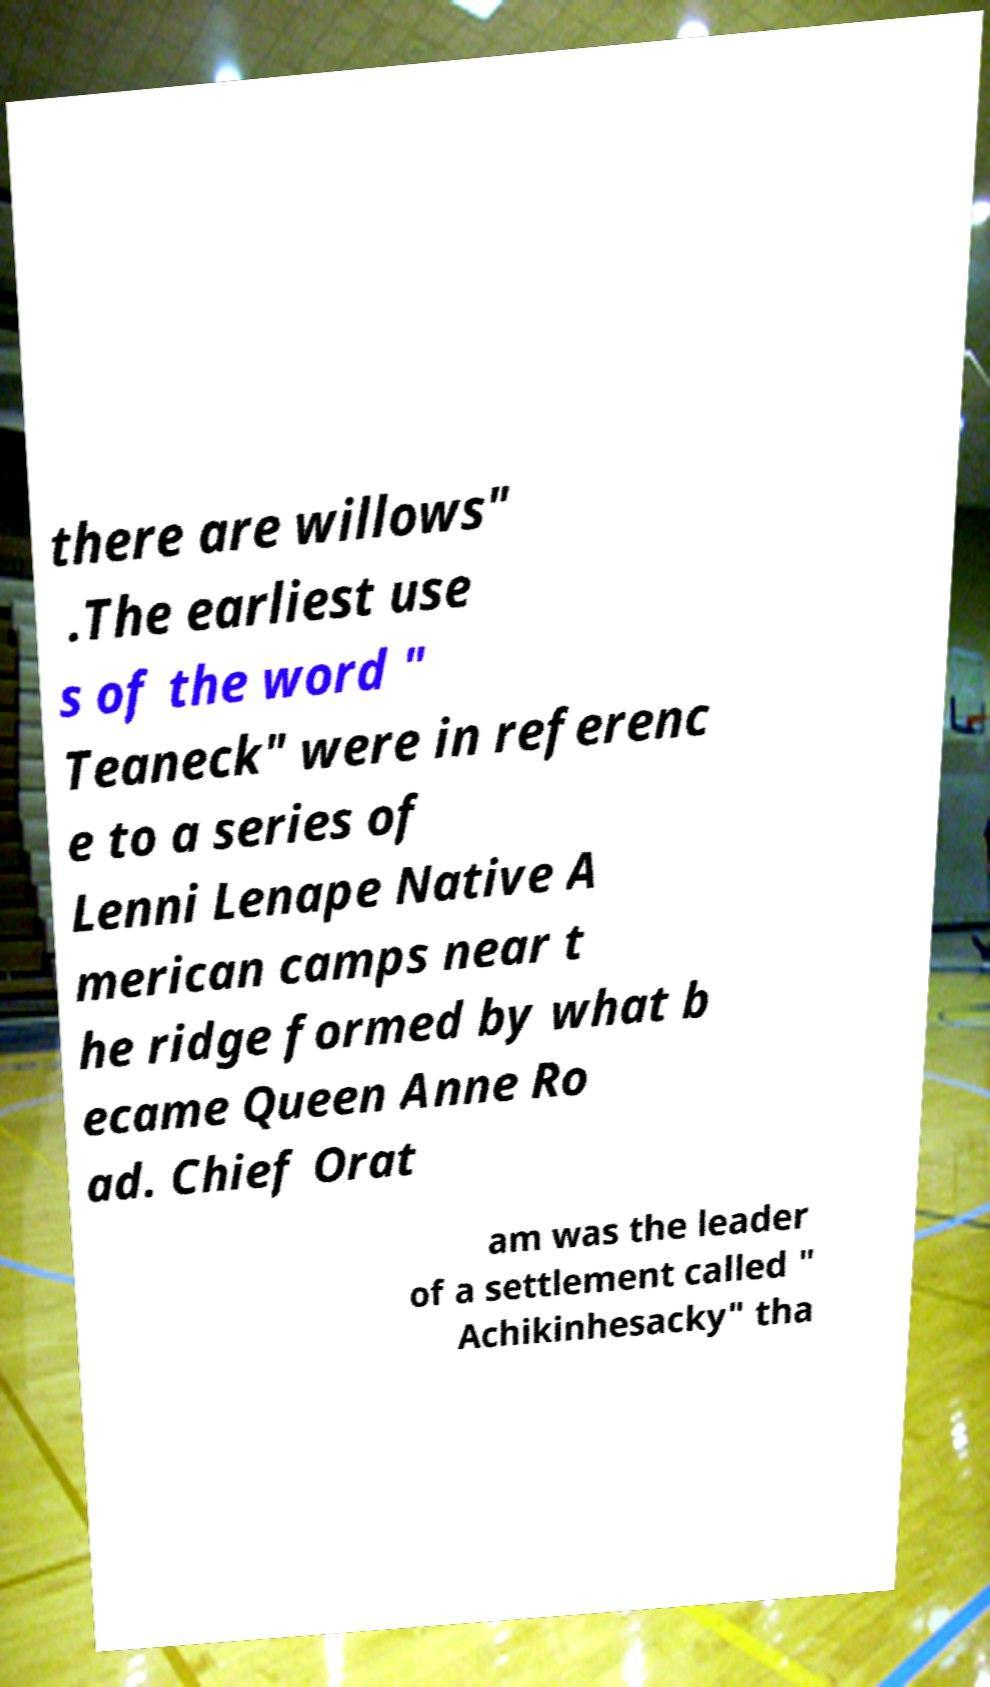Can you read and provide the text displayed in the image?This photo seems to have some interesting text. Can you extract and type it out for me? there are willows" .The earliest use s of the word " Teaneck" were in referenc e to a series of Lenni Lenape Native A merican camps near t he ridge formed by what b ecame Queen Anne Ro ad. Chief Orat am was the leader of a settlement called " Achikinhesacky" tha 